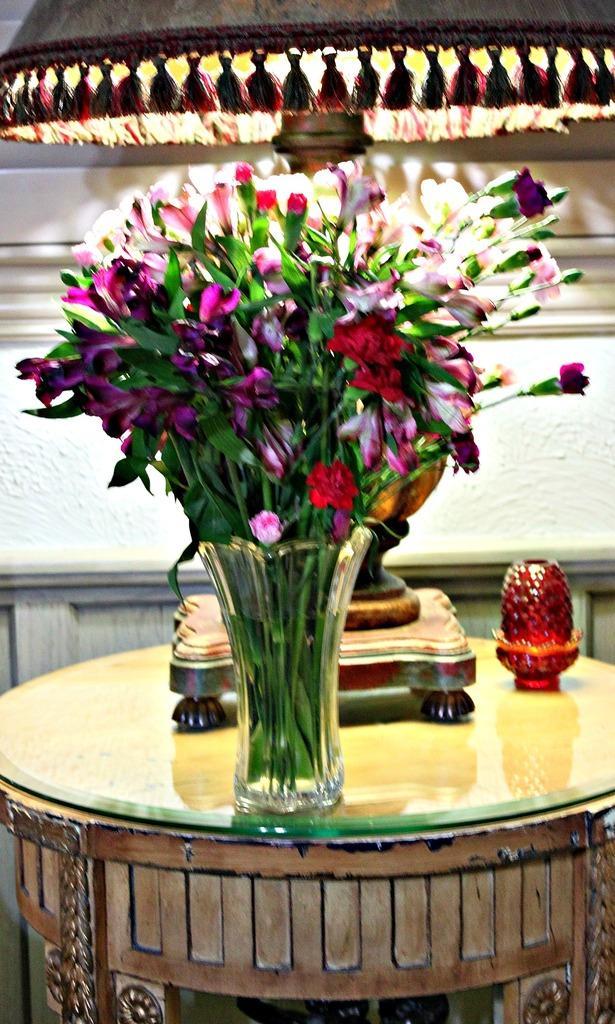In one or two sentences, can you explain what this image depicts? In this picture I can see a flower vase, some objects are placed on the table. 